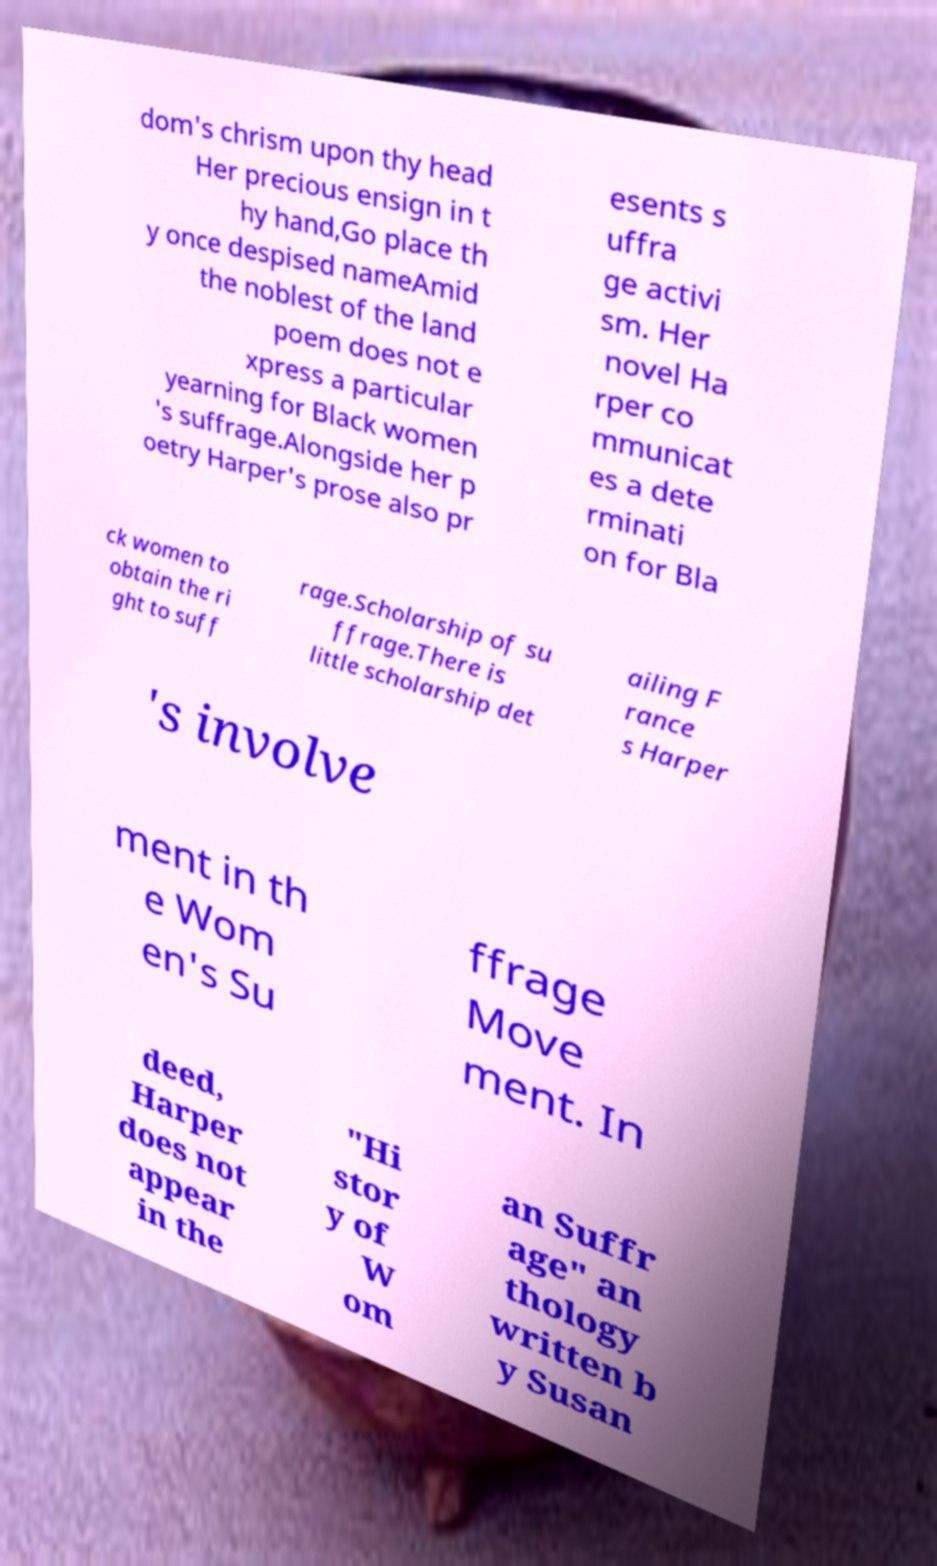Can you accurately transcribe the text from the provided image for me? dom's chrism upon thy head Her precious ensign in t hy hand,Go place th y once despised nameAmid the noblest of the land poem does not e xpress a particular yearning for Black women 's suffrage.Alongside her p oetry Harper's prose also pr esents s uffra ge activi sm. Her novel Ha rper co mmunicat es a dete rminati on for Bla ck women to obtain the ri ght to suff rage.Scholarship of su ffrage.There is little scholarship det ailing F rance s Harper 's involve ment in th e Wom en's Su ffrage Move ment. In deed, Harper does not appear in the "Hi stor y of W om an Suffr age" an thology written b y Susan 